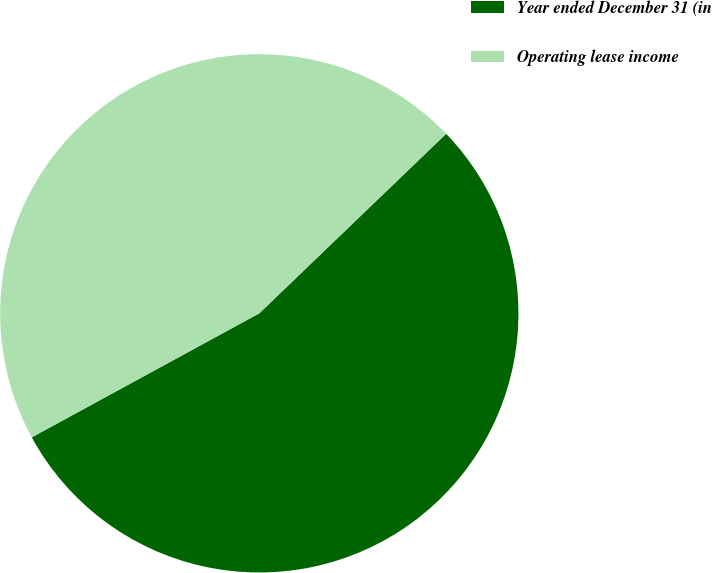Convert chart to OTSL. <chart><loc_0><loc_0><loc_500><loc_500><pie_chart><fcel>Year ended December 31 (in<fcel>Operating lease income<nl><fcel>54.24%<fcel>45.76%<nl></chart> 